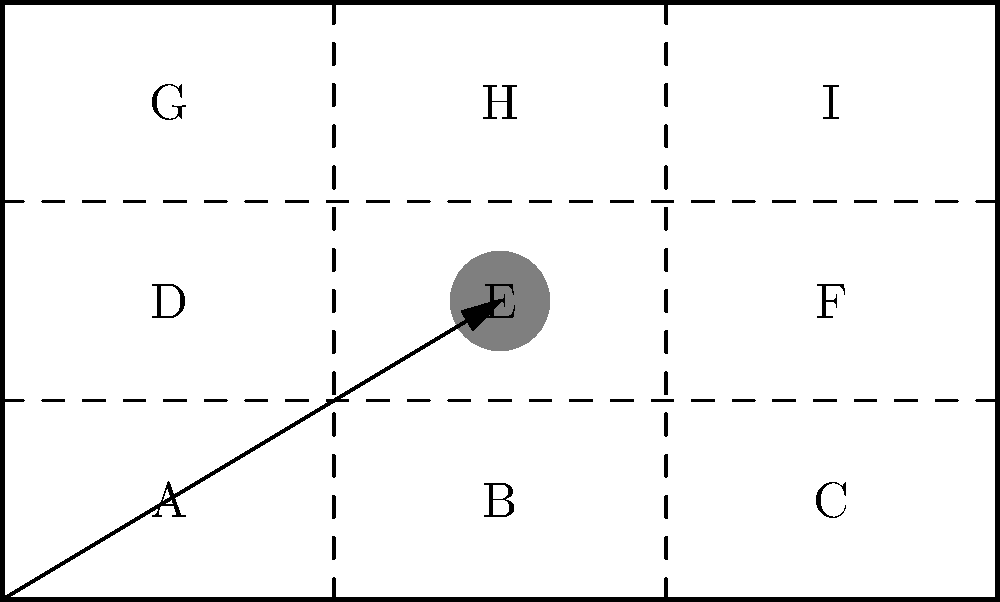Analyze the frame composition diagram above, which represents a shot from a documentary film. Which visual composition technique is primarily illustrated, and how does it contribute to the narrative or emotional impact of the scene? To answer this question, let's analyze the frame composition diagram step-by-step:

1. Rule of Thirds: The frame is divided into a 3x3 grid, representing the rule of thirds. This is a fundamental composition technique in photography and cinematography.

2. Subject Placement: The main subject (represented by the filled circle) is placed at the center of the frame, specifically at point E.

3. Leading Line: There's an arrow pointing from the bottom-left corner to the subject, indicating a leading line.

4. Central Composition: Despite the rule of thirds grid, the subject is placed in the center of the frame.

The primary visual composition technique illustrated here is Central Composition, with the subject placed at the center point (E) of the frame. This technique is often used in documentary filmmaking to:

a) Draw immediate attention to the subject
b) Convey a sense of importance or power
c) Create a symmetrical, balanced frame
d) Isolate the subject from its surroundings

In documentary films, central composition can contribute to the narrative or emotional impact by:

1. Emphasizing the subject's significance in the story
2. Creating a direct, confrontational feeling between the subject and the viewer
3. Conveying a sense of stability or immovability
4. Isolating the subject for in-depth analysis or contemplation

The leading line (arrow) further reinforces the focus on the centrally-placed subject, guiding the viewer's eye directly to it.

While the rule of thirds grid is present, it's not the primary technique used in this composition. Instead, it serves as a contrast to highlight the deliberate choice of central placement.
Answer: Central Composition, emphasizing subject importance and creating direct viewer engagement. 